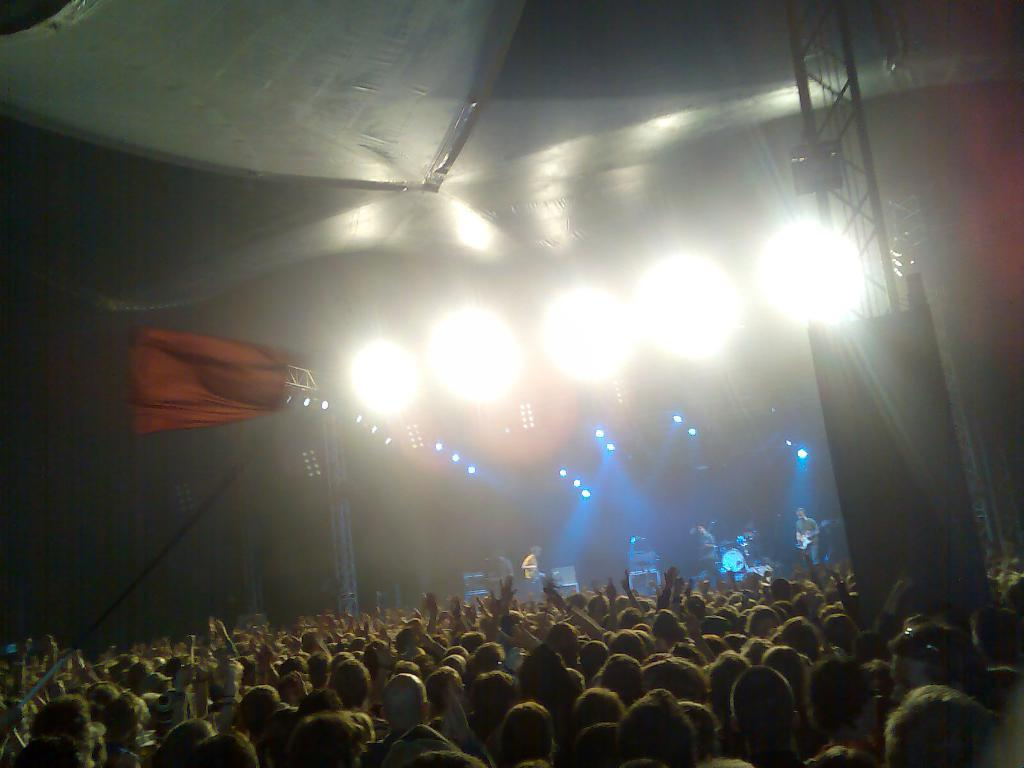What is happening in the image? There are people standing in the image. Can you describe the lighting in the image? There are lights visible in the image. What type of bike is the brother riding in the image? There is no brother or bike present in the image. 